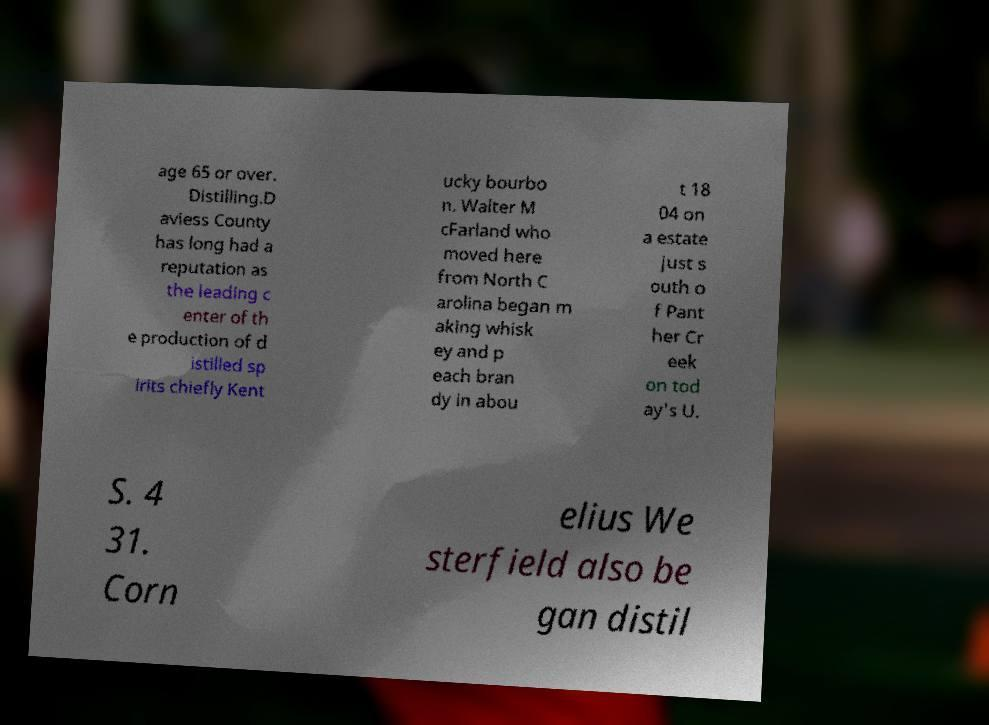What messages or text are displayed in this image? I need them in a readable, typed format. age 65 or over. Distilling.D aviess County has long had a reputation as the leading c enter of th e production of d istilled sp irits chiefly Kent ucky bourbo n. Walter M cFarland who moved here from North C arolina began m aking whisk ey and p each bran dy in abou t 18 04 on a estate just s outh o f Pant her Cr eek on tod ay's U. S. 4 31. Corn elius We sterfield also be gan distil 